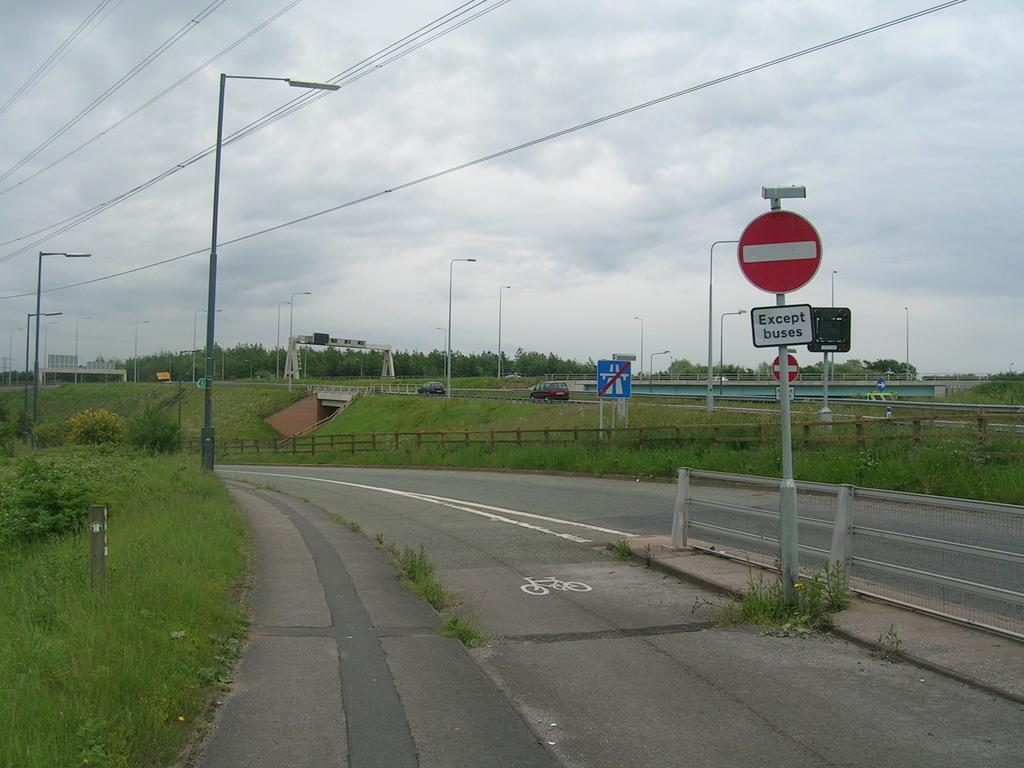<image>
Summarize the visual content of the image. One may not park on this road unless they are driving a bus. 